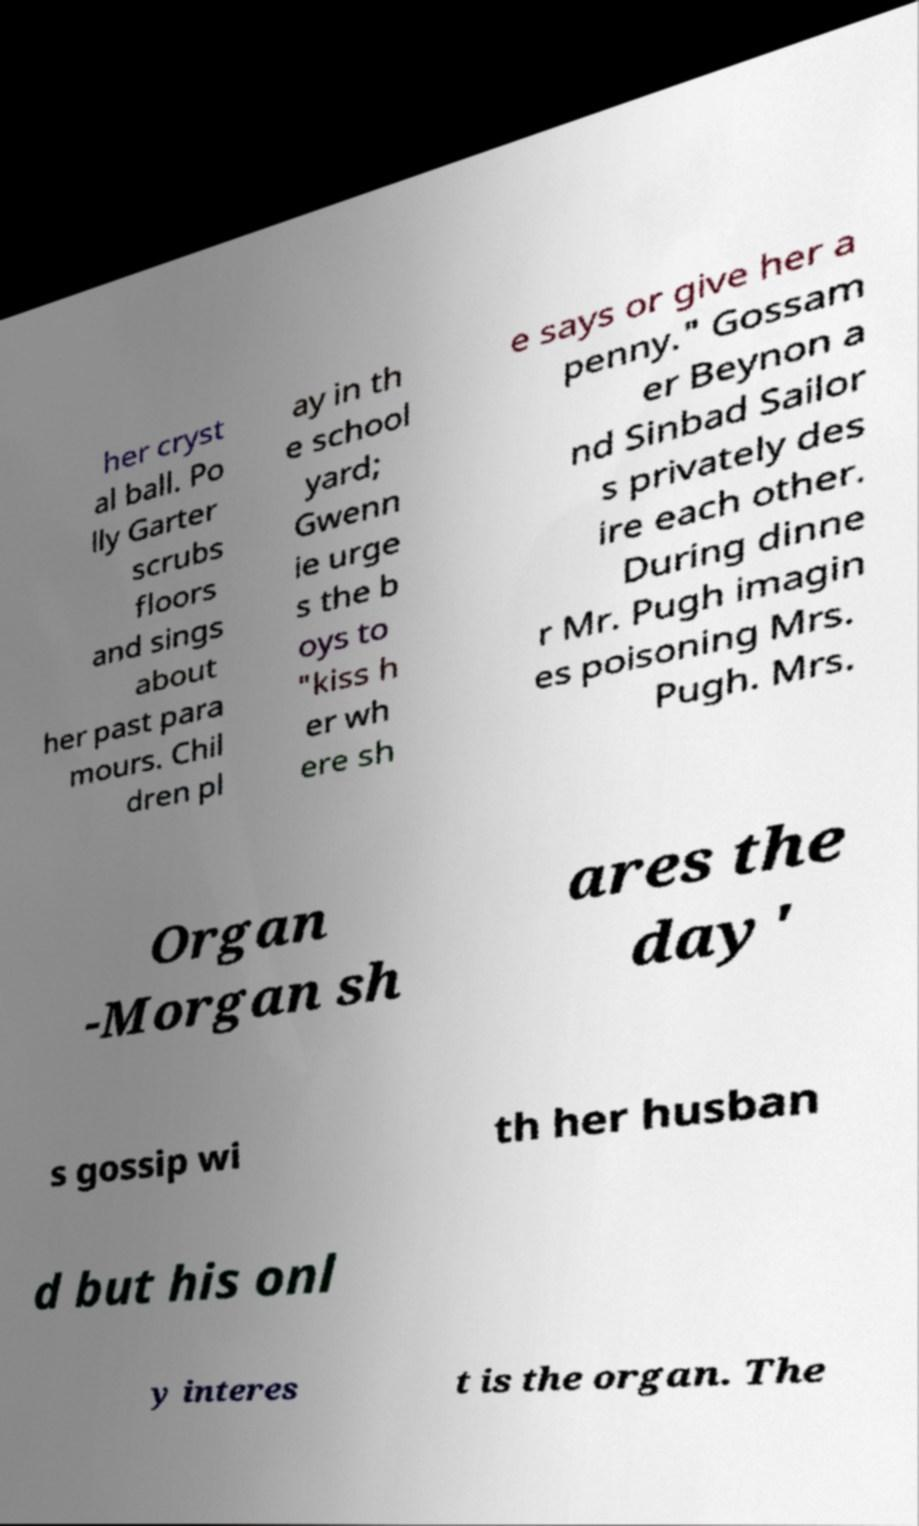Please read and relay the text visible in this image. What does it say? her cryst al ball. Po lly Garter scrubs floors and sings about her past para mours. Chil dren pl ay in th e school yard; Gwenn ie urge s the b oys to "kiss h er wh ere sh e says or give her a penny." Gossam er Beynon a nd Sinbad Sailor s privately des ire each other. During dinne r Mr. Pugh imagin es poisoning Mrs. Pugh. Mrs. Organ -Morgan sh ares the day' s gossip wi th her husban d but his onl y interes t is the organ. The 